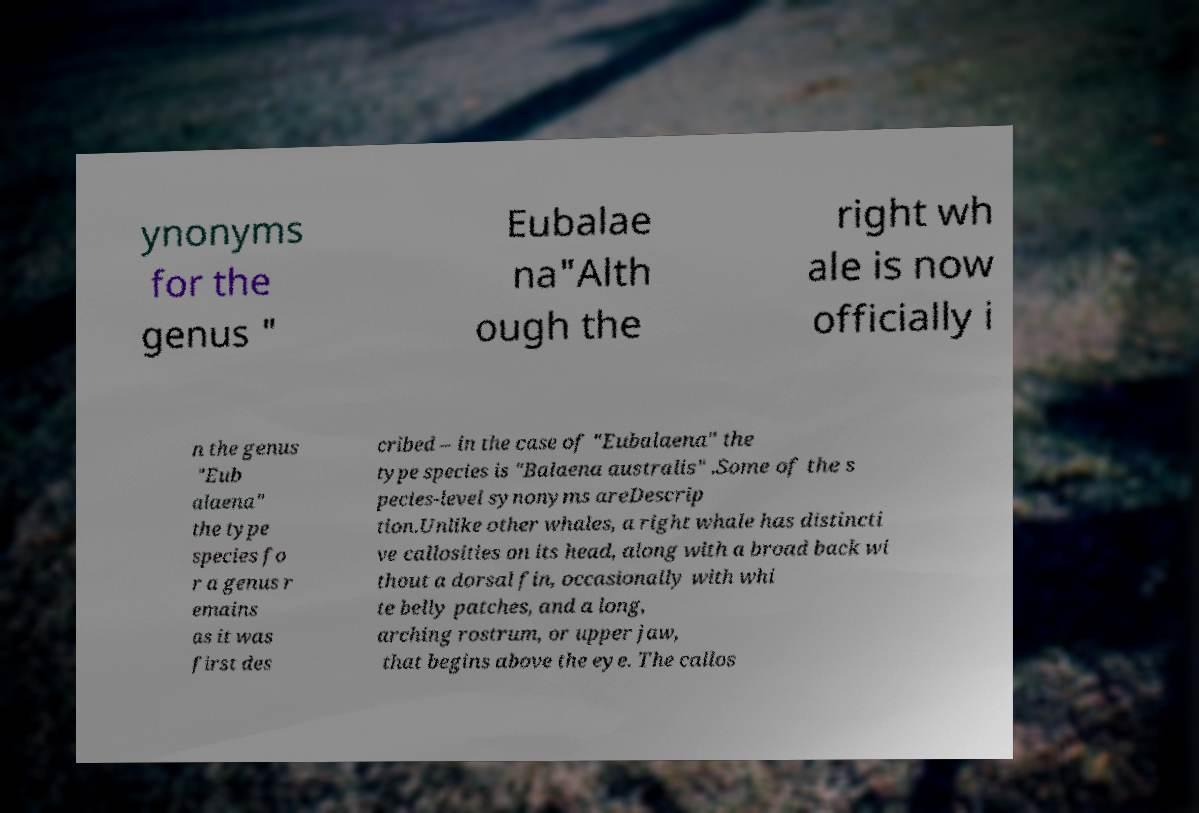There's text embedded in this image that I need extracted. Can you transcribe it verbatim? ynonyms for the genus " Eubalae na"Alth ough the right wh ale is now officially i n the genus "Eub alaena" the type species fo r a genus r emains as it was first des cribed – in the case of "Eubalaena" the type species is "Balaena australis" .Some of the s pecies-level synonyms areDescrip tion.Unlike other whales, a right whale has distincti ve callosities on its head, along with a broad back wi thout a dorsal fin, occasionally with whi te belly patches, and a long, arching rostrum, or upper jaw, that begins above the eye. The callos 